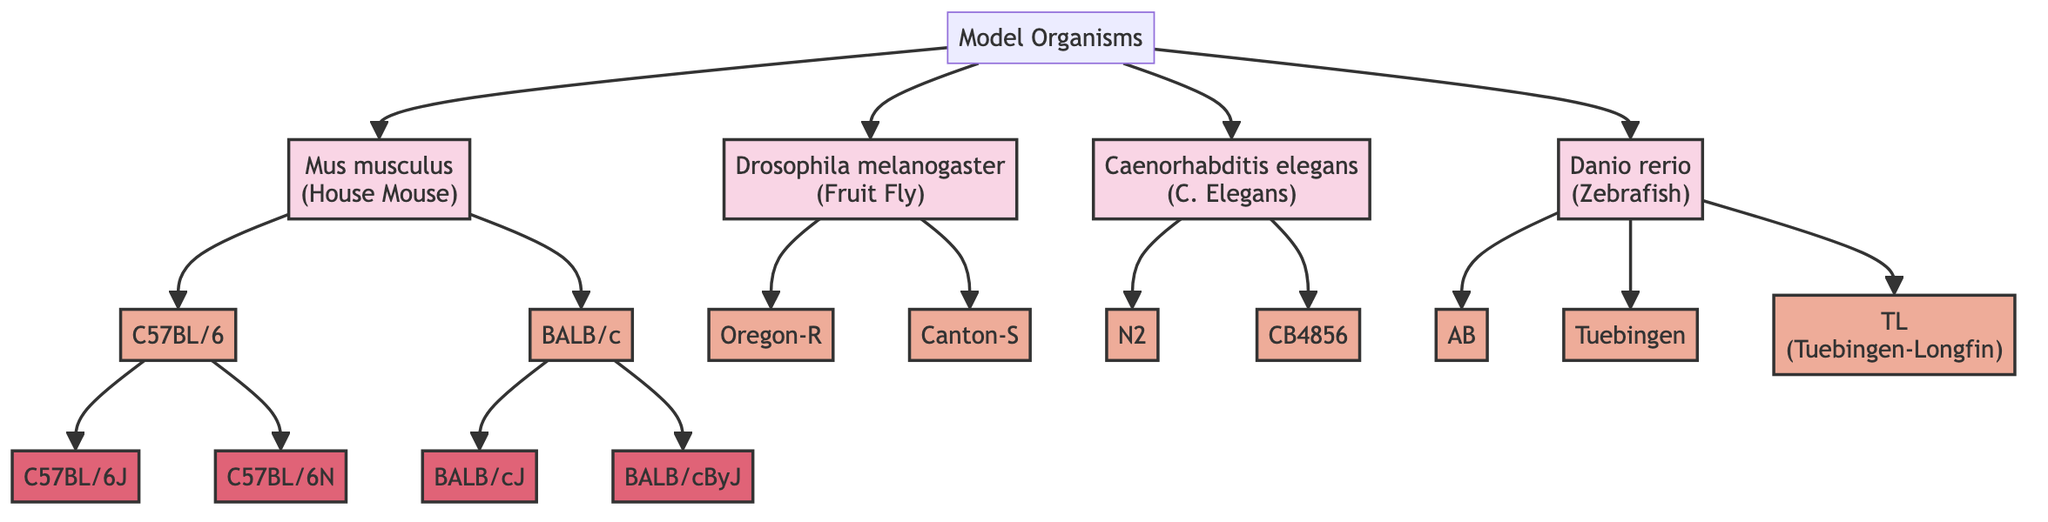What organism is represented as "House Mouse"? The diagram shows that "Mus musculus" is the organism commonly known as "House Mouse." This relationship is established by tracing the line from the Root labeled "Model Organisms" to the node labeled "Mus musculus (House Mouse)."
Answer: Mus musculus How many strains are listed under "Mus musculus"? In the diagram, "Mus musculus" branches out to two strains: "C57BL/6" and "BALB/c." Therefore, counting these gives us a total of two strains.
Answer: 2 What are the two sub-strains of "C57BL/6"? By examining the node "C57BL/6," we can see that it connects to two sub-strains listed: "C57BL/6J" and "C57BL/6N." These can be found by following the branches from the "C57BL/6" strain node.
Answer: C57BL/6J, C57BL/6N Which strain is used in immunology research? The diagram indicates that the "BALB/c" strain under "Mus musculus" is commonly utilized in immunology and cancer research. This information is available from the description connected to the "BALB/c" node.
Answer: BALB/c What is the common name for "Caenorhabditis elegans"? Tracing the diagram back from "Caenorhabditis elegans," we find that it is commonly referred to as "C. Elegans." This connection is clearly labeled next to the organism in the diagram.
Answer: C. Elegans Which organism has a strain named "Oregon-R"? The node for "Drosophila melanogaster" branches to a strain called "Oregon-R." By following the path from the Root node to the "Drosophila melanogaster" node and then to its strain, we conclude that the organism is "Drosophila melanogaster."
Answer: Drosophila melanogaster How many strains does "Danio rerio" have? From the diagram, "Danio rerio" has three strains: "AB," "Tuebingen," and "TL (Tuebingen-Longfin)." Counting these strains provides the answer.
Answer: 3 Which sub-strain of "BALB/c" is valuable for studies on immune response? Within the "BALB/c" node, the sub-strain "BALB/cJ" is specifically mentioned as valuable for studies on immune response and infectious diseases. This information can be derived from its description beside the node.
Answer: BALB/cJ What is the primary focus of studies involving the strain "TL"? The strain labeled "TL" under "Danio rerio" is used specifically for developmental studies due to its large fins. This information is directly associated with the description of the strain in the diagram.
Answer: Developmental studies 